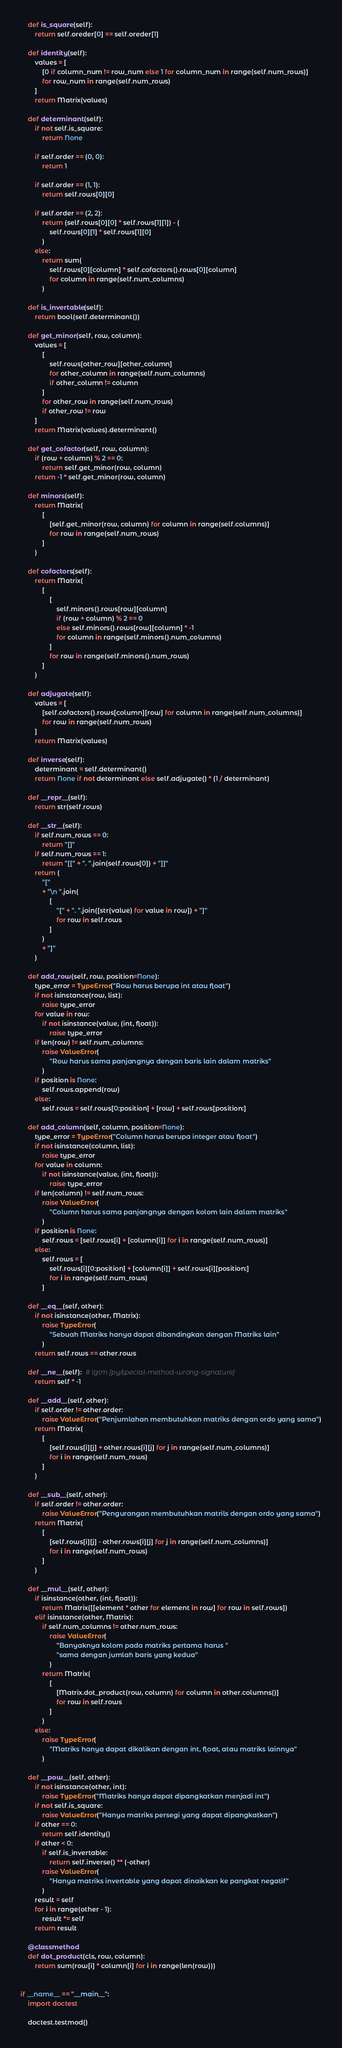<code> <loc_0><loc_0><loc_500><loc_500><_Python_>    def is_square(self):
        return self.oreder[0] == self.oreder[1]

    def identity(self):
        values = [
            [0 if column_num != row_num else 1 for column_num in range(self.num_rows)]
            for row_num in range(self.num_rows)
        ]
        return Matrix(values)

    def determinant(self):
        if not self.is_square:
            return None

        if self.order == (0, 0):
            return 1

        if self.order == (1, 1):
            return self.rows[0][0]

        if self.order == (2, 2):
            return (self.rows[0][0] * self.rows[1][1]) - (
                self.rows[0][1] * self.rows[1][0]
            )
        else:
            return sum(
                self.rows[0][column] * self.cofactors().rows[0][column]
                for column in range(self.num_columns)
            )

    def is_invertable(self):
        return bool(self.determinant())

    def get_minor(self, row, column):
        values = [
            [
                self.rows[other_row][other_column]
                for other_column in range(self.num_columns)
                if other_column != column
            ]
            for other_row in range(self.num_rows)
            if other_row != row
        ]
        return Matrix(values).determinant()

    def get_cofactor(self, row, column):
        if (row + column) % 2 == 0:
            return self.get_minor(row, column)
        return -1 * self.get_minor(row, column)

    def minors(self):
        return Matrix(
            [
                [self.get_minor(row, column) for column in range(self.columns)]
                for row in range(self.num_rows)
            ]
        )

    def cofactors(self):
        return Matrix(
            [
                [
                    self.minors().rows[row][column]
                    if (row + column) % 2 == 0
                    else self.minors().rows[row][column] * -1
                    for column in range(self.minors().num_columns)
                ]
                for row in range(self.minors().num_rows)
            ]
        )

    def adjugate(self):
        values = [
            [self.cofactors().rows[column][row] for column in range(self.num_columns)]
            for row in range(self.num_rows)
        ]
        return Matrix(values)

    def inverse(self):
        determinant = self.determinant()
        return None if not determinant else self.adjugate() * (1 / determinant)

    def __repr__(self):
        return str(self.rows)

    def __str__(self):
        if self.num_rows == 0:
            return "[]"
        if self.num_rows == 1:
            return "[[" + ". ".join(self.rows[0]) + "]]"
        return (
            "["
            + "\n ".join(
                [
                    "[" + ". ".join([str(value) for value in row]) + "]"
                    for row in self.rows
                ]
            )
            + "]"
        )

    def add_row(self, row, position=None):
        type_error = TypeError("Row harus berupa int atau float")
        if not isinstance(row, list):
            raise type_error
        for value in row:
            if not isinstance(value, (int, float)):
                raise type_error
        if len(row) != self.num_columns:
            raise ValueError(
                "Row harus sama panjangnya dengan baris lain dalam matriks"
            )
        if position is None:
            self.rows.append(row)
        else:
            self.rows = self.rows[0:position] + [row] + self.rows[position:]

    def add_column(self, column, position=None):
        type_error = TypeError("Column harus berupa integer atau float")
        if not isinstance(column, list):
            raise type_error
        for value in column:
            if not isinstance(value, (int, float)):
                raise type_error
        if len(column) != self.num_rows:
            raise ValueError(
                "Column harus sama panjangnya dengan kolom lain dalam matriks"
            )
        if position is None:
            self.rows = [self.rows[i] + [column[i]] for i in range(self.num_rows)]
        else:
            self.rows = [
                self.rows[i][0:position] + [column[i]] + self.rows[i][position:]
                for i in range(self.num_rows)
            ]

    def __eq__(self, other):
        if not isinstance(other, Matrix):
            raise TypeError(
                "Sebuah Matriks hanya dapat dibandingkan dengan Matriks lain"
            )
        return self.rows == other.rows

    def __ne__(self):  # lgtm [py/special-method-wrong-signature]
        return self * -1

    def __add__(self, other):
        if self.order != other.order:
            raise ValueError("Penjumlahan membutuhkan matriks dengan ordo yang sama")
        return Matrix(
            [
                [self.rows[i][j] + other.rows[i][j] for j in range(self.num_columns)]
                for i in range(self.num_rows)
            ]
        )

    def __sub__(self, other):
        if self.order != other.order:
            raise ValueError("Pengurangan membutuhkan matrils dengan ordo yang sama")
        return Matrix(
            [
                [self.rows[i][j] - other.rows[i][j] for j in range(self.num_columns)]
                for i in range(self.num_rows)
            ]
        )

    def __mul__(self, other):
        if isinstance(other, (int, float)):
            return Matrix([[element * other for element in row] for row in self.rows])
        elif isinstance(other, Matrix):
            if self.num_columns != other.num_rows:
                raise ValueError(
                    "Banyaknya kolom pada matriks pertama harus "
                    "sama dengan jumlah baris yang kedua"
                )
            return Matrix(
                [
                    [Matrix.dot_product(row, column) for column in other.columns()]
                    for row in self.rows
                ]
            )
        else:
            raise TypeError(
                "Matriks hanya dapat dikalikan dengan int, float, atau matriks lainnya"
            )

    def __pow__(self, other):
        if not isinstance(other, int):
            raise TypeError("Matriks hanya dapat dipangkatkan menjadi int")
        if not self.is_square:
            raise ValueError("Hanya matriks persegi yang dapat dipangkatkan")
        if other == 0:
            return self.identity()
        if other < 0:
            if self.is_invertable:
                return self.inverse() ** (-other)
            raise ValueError(
                "Hanya matriks invertable yang dapat dinaikkan ke pangkat negatif"
            )
        result = self
        for i in range(other - 1):
            result *= self
        return result

    @classmethod
    def dot_product(cls, row, column):
        return sum(row[i] * column[i] for i in range(len(row)))


if __name__ == "__main__":
    import doctest

    doctest.testmod()
</code> 